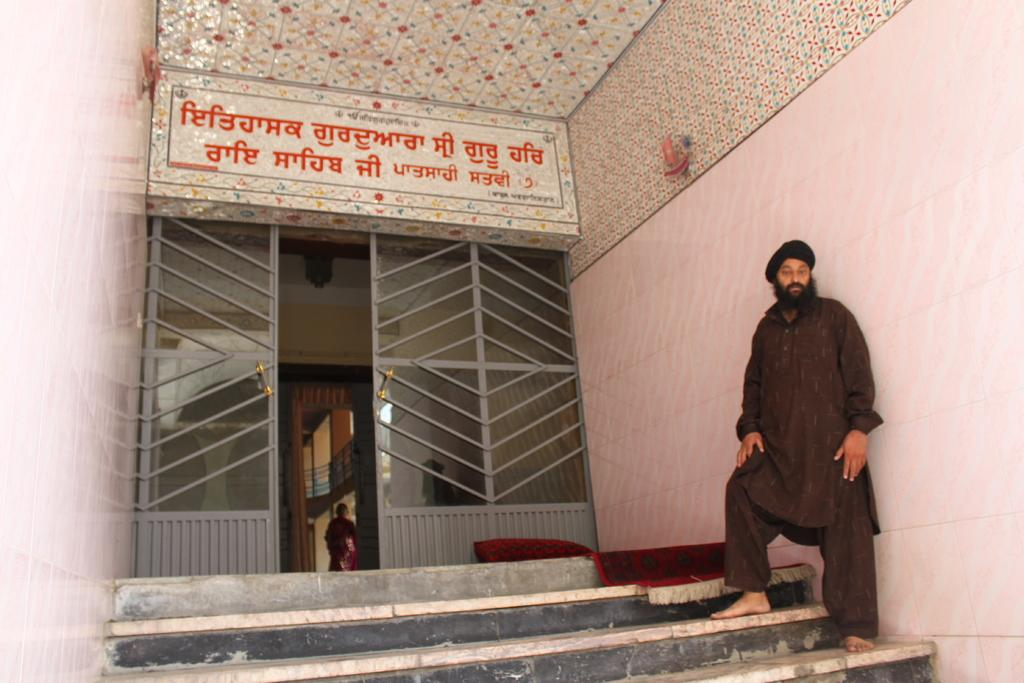Who or what is in the image? There is a person in the image. What is the person doing in the image? The person is standing on stairs. Where are the stairs located in relation to the house? The stairs are in front of a house. How many cacti are visible in the image? There are no cacti present in the image. 